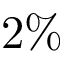Convert formula to latex. <formula><loc_0><loc_0><loc_500><loc_500>2 \%</formula> 